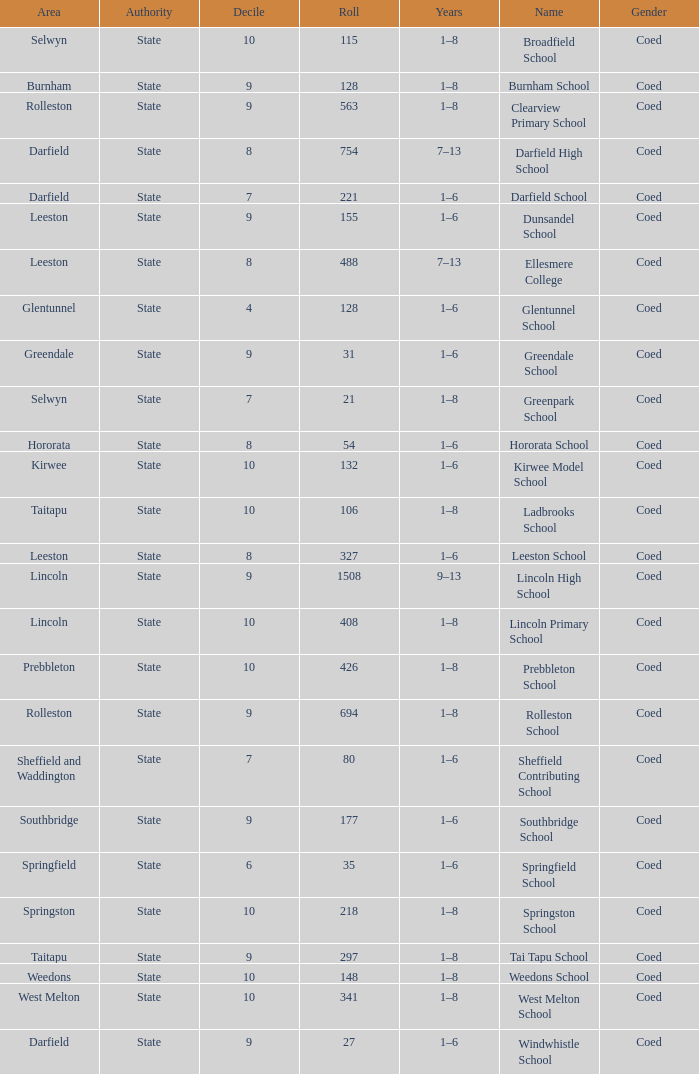How many deciles have Years of 9–13? 1.0. 